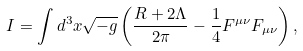Convert formula to latex. <formula><loc_0><loc_0><loc_500><loc_500>I = \int d ^ { 3 } x \sqrt { - g } \left ( \frac { R + 2 \Lambda } { 2 \pi } - \frac { 1 } { 4 } F ^ { \mu \nu } F _ { \mu \nu } \right ) ,</formula> 